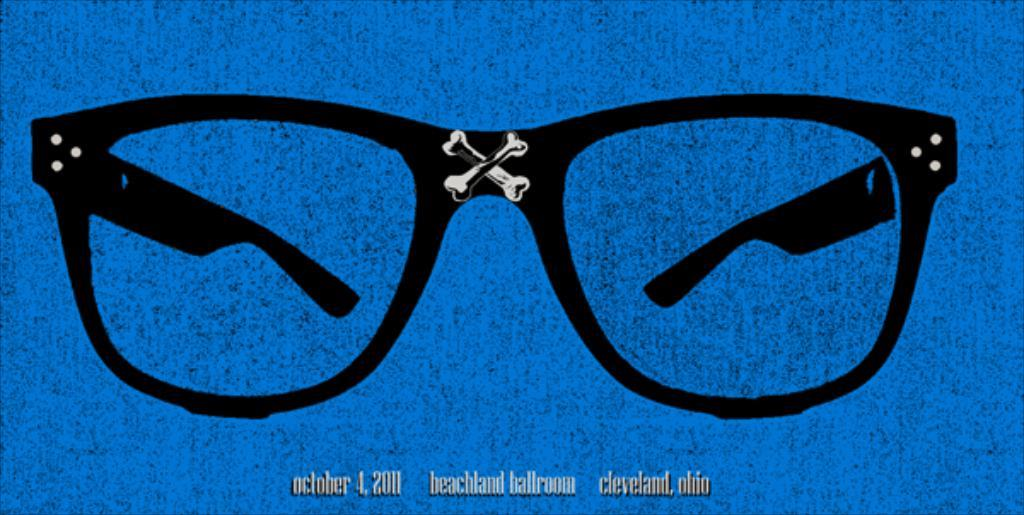What color can be seen in the form of specs in the image? There are black color specs in the image. What is the color of the background in the image? The background of the image is blue. Can you tell me how many loaves of bread are present in the image? There is no bread present in the image; it only features black color specs and a blue background. How many volleyballs can be seen in the image? There are no volleyballs present in the image. 